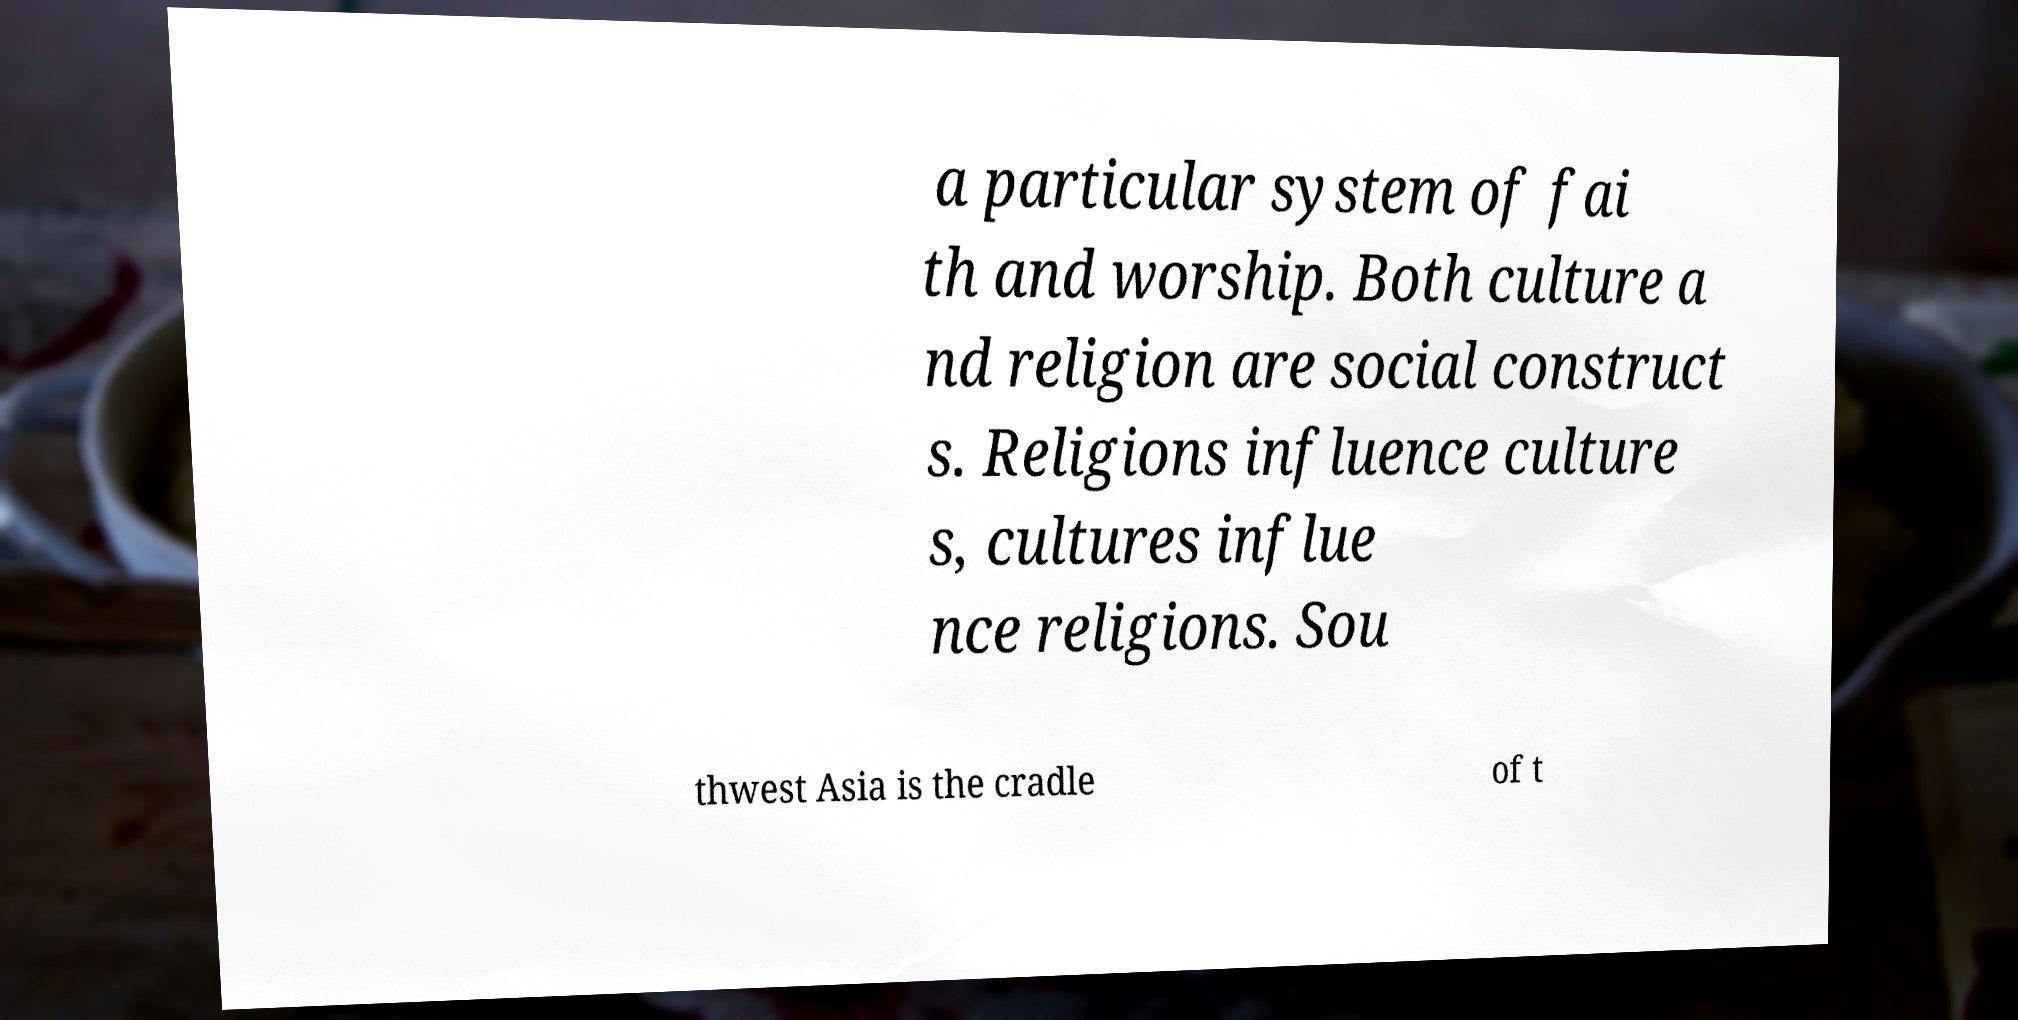There's text embedded in this image that I need extracted. Can you transcribe it verbatim? a particular system of fai th and worship. Both culture a nd religion are social construct s. Religions influence culture s, cultures influe nce religions. Sou thwest Asia is the cradle of t 